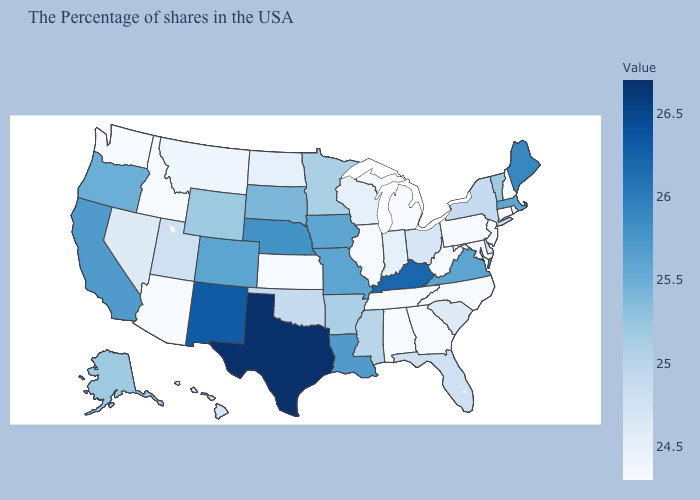Is the legend a continuous bar?
Concise answer only. Yes. Which states have the lowest value in the MidWest?
Write a very short answer. Michigan, Illinois, Kansas. Does Wyoming have the lowest value in the West?
Quick response, please. No. Among the states that border Rhode Island , which have the highest value?
Give a very brief answer. Massachusetts. Does Massachusetts have a lower value than Alabama?
Write a very short answer. No. Does Indiana have the highest value in the USA?
Write a very short answer. No. Among the states that border Mississippi , which have the highest value?
Concise answer only. Louisiana. 